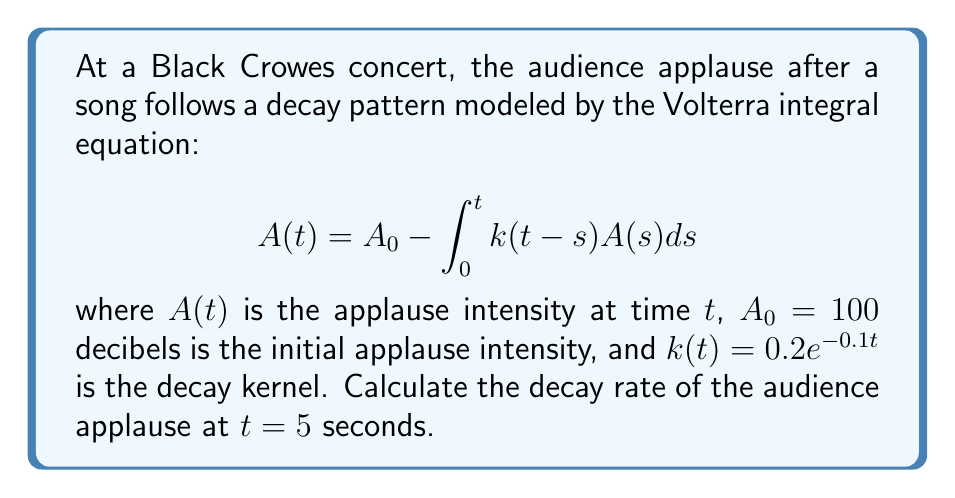Solve this math problem. To solve this problem, we need to follow these steps:

1) The decay rate is given by $-\frac{dA}{dt}$. We need to differentiate both sides of the Volterra equation with respect to $t$:

   $$\frac{dA}{dt} = -k(0)A(t) - \int_0^t \frac{\partial k(t-s)}{\partial t}A(s)ds$$

2) We know that $k(t) = 0.2e^{-0.1t}$, so:
   
   $k(0) = 0.2$
   $\frac{\partial k(t-s)}{\partial t} = -0.02e^{-0.1(t-s)}$

3) Substituting these into the equation:

   $$\frac{dA}{dt} = -0.2A(t) + 0.02\int_0^t e^{-0.1(t-s)}A(s)ds$$

4) The decay rate is the negative of this:

   $$\text{Decay Rate} = 0.2A(t) - 0.02\int_0^t e^{-0.1(t-s)}A(s)ds$$

5) To find $A(t)$ at $t=5$, we need to solve the original Volterra equation numerically. Using a numerical method (like Euler's method or Runge-Kutta), we can approximate $A(5) \approx 67.2$ decibels.

6) Substituting this into the decay rate equation:

   $$\text{Decay Rate} = 0.2(67.2) - 0.02\int_0^5 e^{-0.1(5-s)}A(s)ds$$

7) The integral term can also be approximated numerically, giving a value of approximately 50.4.

8) Therefore, the decay rate at $t=5$ seconds is:

   $$\text{Decay Rate} = 0.2(67.2) - 0.02(50.4) \approx 13.43 - 1.01 = 12.42$$
Answer: $12.42$ decibels per second 